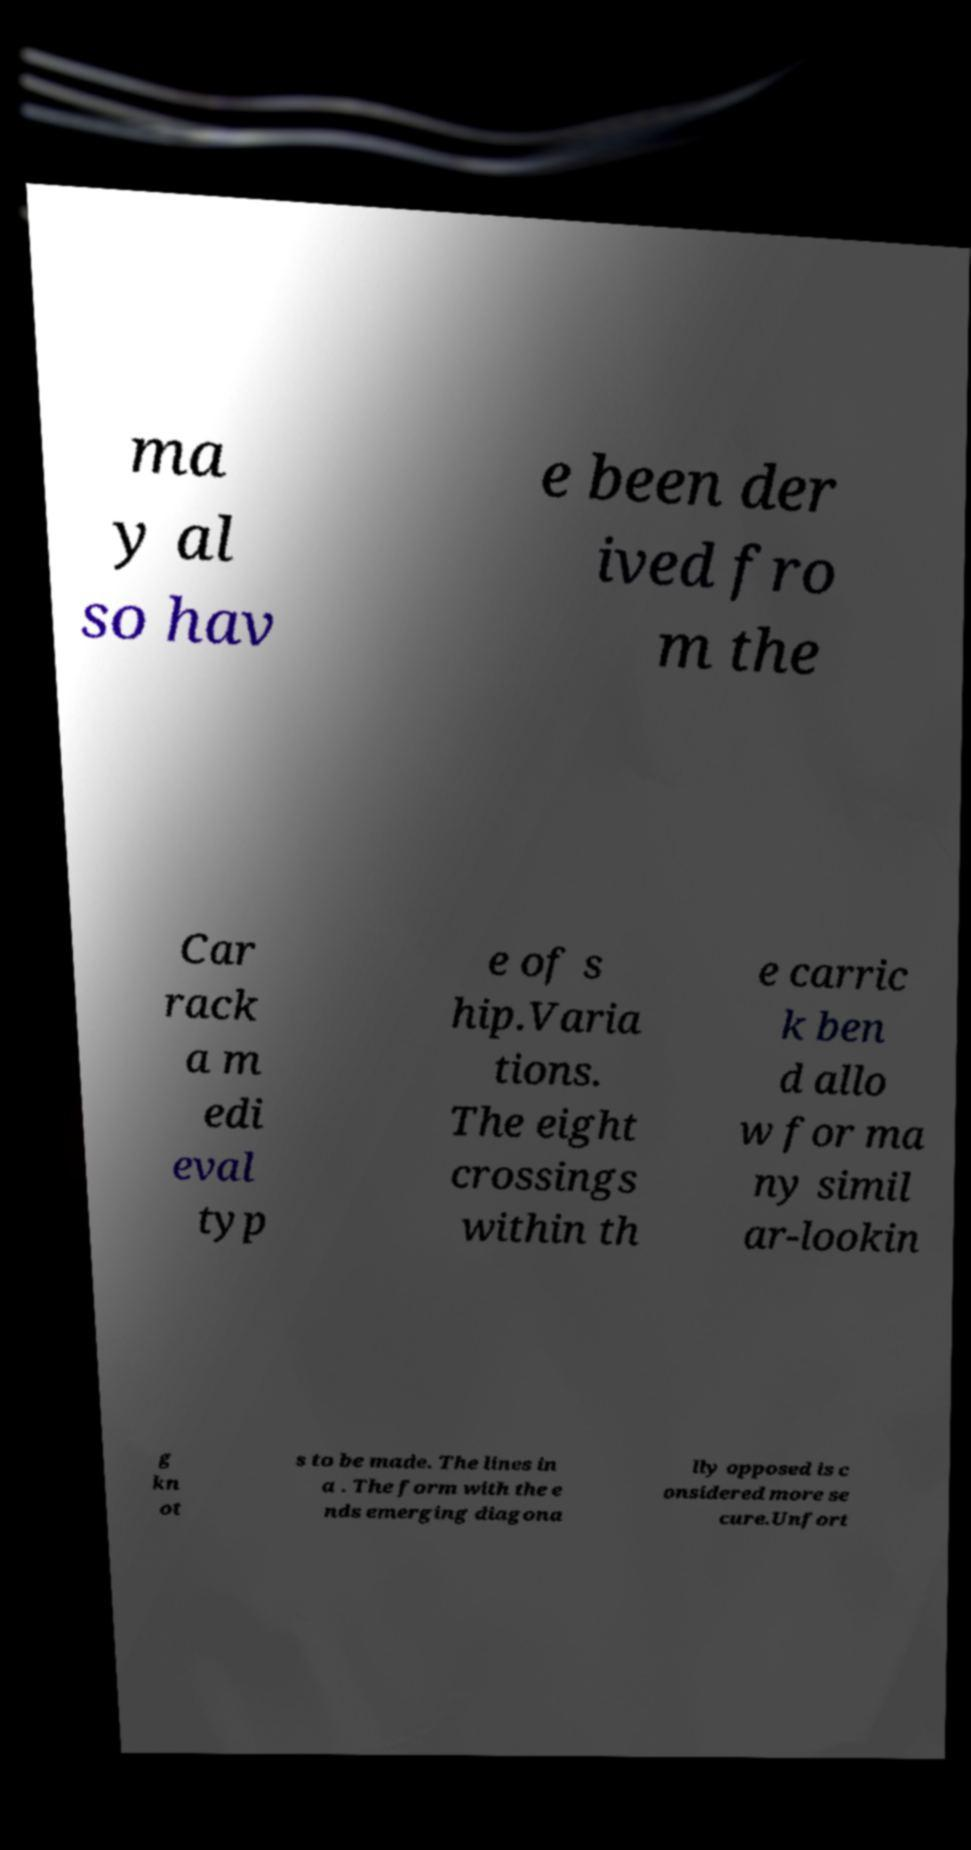Can you read and provide the text displayed in the image?This photo seems to have some interesting text. Can you extract and type it out for me? ma y al so hav e been der ived fro m the Car rack a m edi eval typ e of s hip.Varia tions. The eight crossings within th e carric k ben d allo w for ma ny simil ar-lookin g kn ot s to be made. The lines in a . The form with the e nds emerging diagona lly opposed is c onsidered more se cure.Unfort 